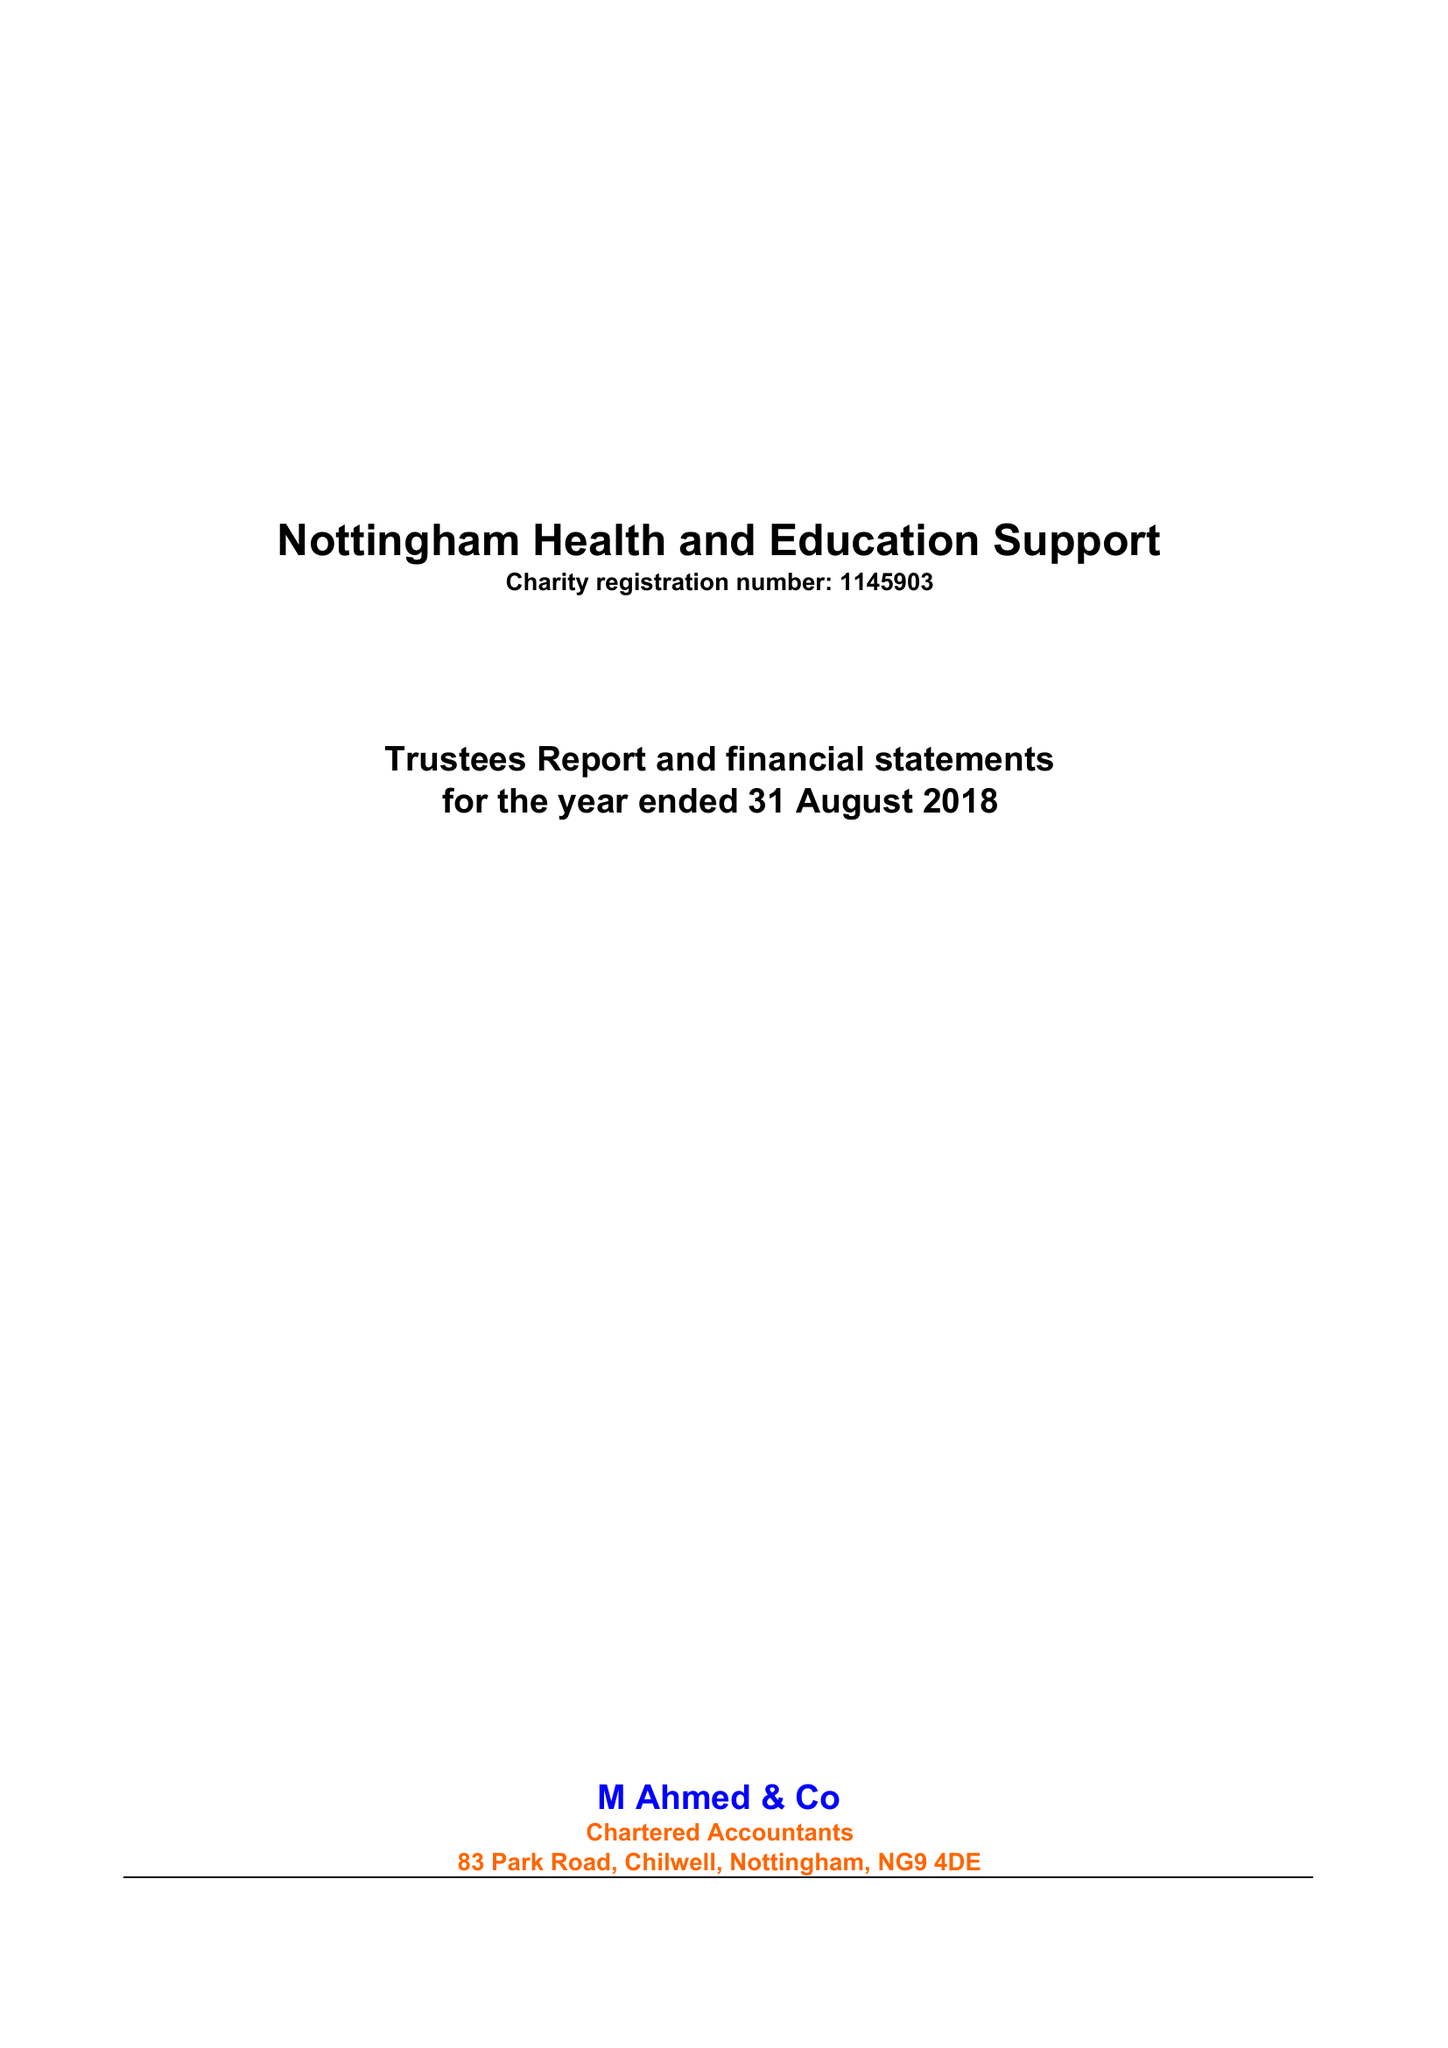What is the value for the address__postcode?
Answer the question using a single word or phrase. NG3 6JX 